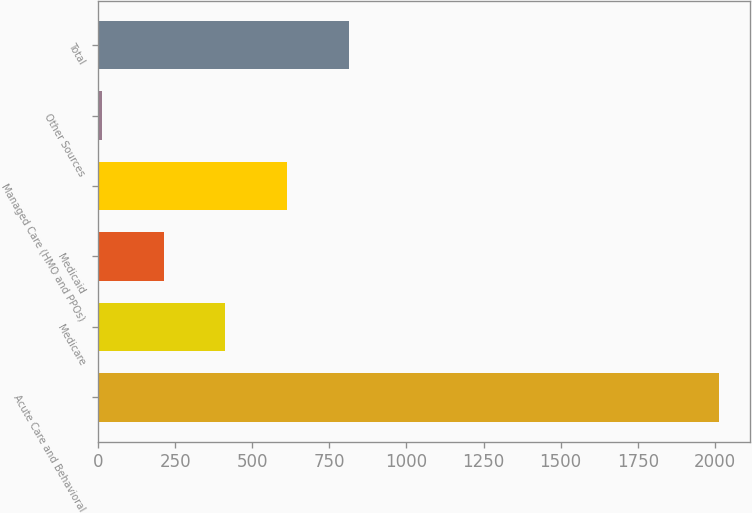Convert chart to OTSL. <chart><loc_0><loc_0><loc_500><loc_500><bar_chart><fcel>Acute Care and Behavioral<fcel>Medicare<fcel>Medicaid<fcel>Managed Care (HMO and PPOs)<fcel>Other Sources<fcel>Total<nl><fcel>2013<fcel>413<fcel>213<fcel>613<fcel>13<fcel>813<nl></chart> 